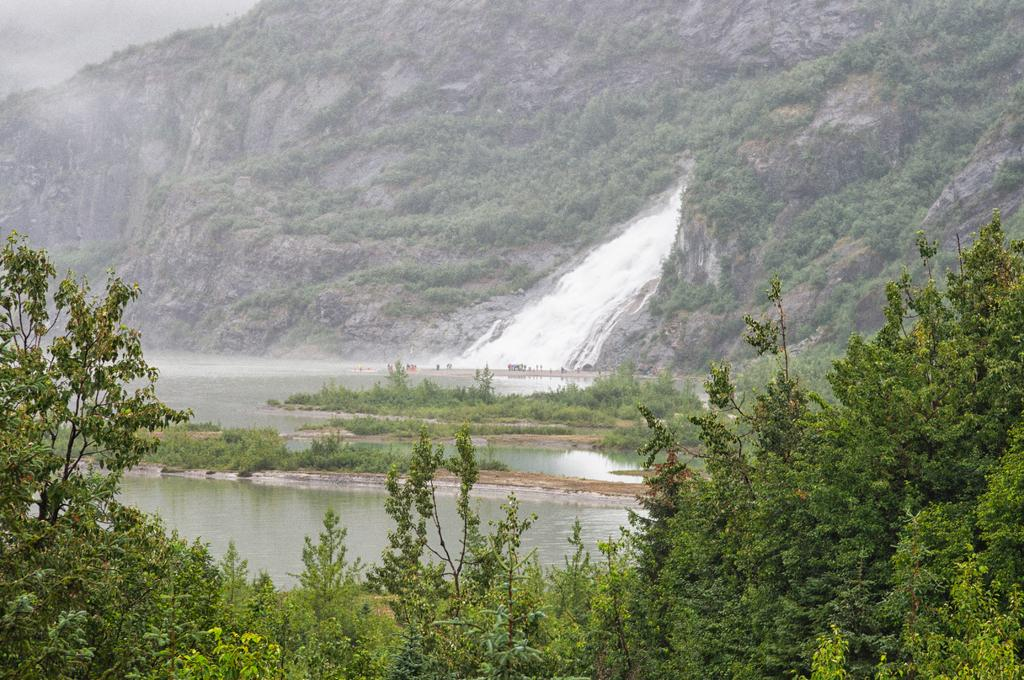What type of vegetation can be seen in the image? There are trees and plants in the image. What natural element is visible in the image? There is water visible in the image. What can be seen in the background of the image? There is a mountain in the background of the image. What type of vest is being worn by the quince in the image? There is no quince or vest present in the image. 